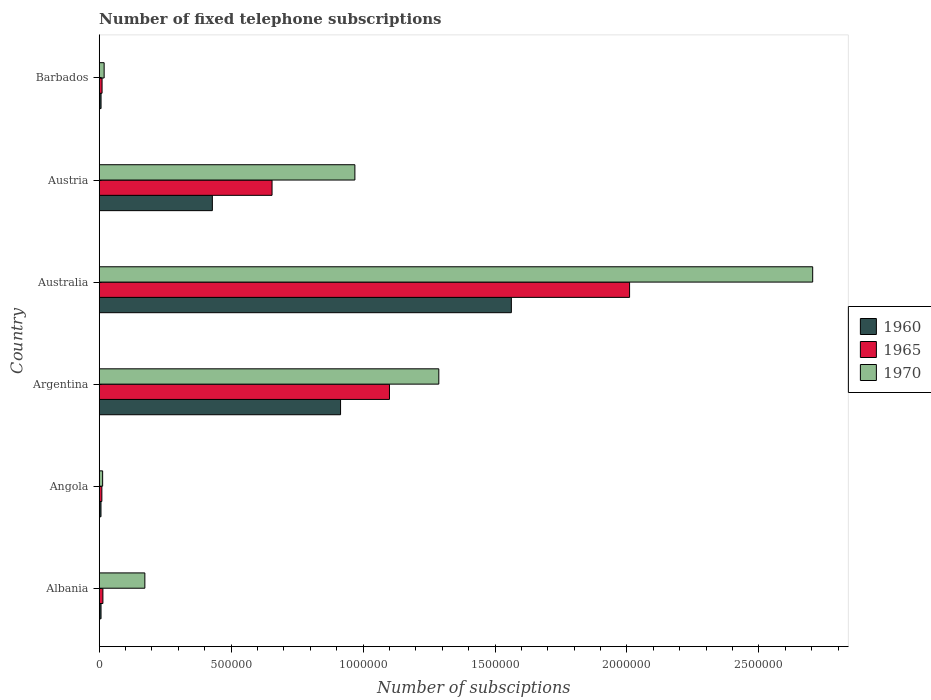How many different coloured bars are there?
Make the answer very short. 3. Are the number of bars per tick equal to the number of legend labels?
Make the answer very short. Yes. Are the number of bars on each tick of the Y-axis equal?
Provide a succinct answer. Yes. How many bars are there on the 5th tick from the bottom?
Your answer should be very brief. 3. What is the label of the 4th group of bars from the top?
Offer a very short reply. Argentina. In how many cases, is the number of bars for a given country not equal to the number of legend labels?
Make the answer very short. 0. What is the number of fixed telephone subscriptions in 1970 in Barbados?
Offer a terse response. 1.87e+04. Across all countries, what is the maximum number of fixed telephone subscriptions in 1970?
Your answer should be compact. 2.70e+06. Across all countries, what is the minimum number of fixed telephone subscriptions in 1970?
Keep it short and to the point. 1.30e+04. In which country was the number of fixed telephone subscriptions in 1965 minimum?
Give a very brief answer. Angola. What is the total number of fixed telephone subscriptions in 1960 in the graph?
Provide a succinct answer. 2.93e+06. What is the difference between the number of fixed telephone subscriptions in 1965 in Albania and that in Austria?
Ensure brevity in your answer.  -6.41e+05. What is the difference between the number of fixed telephone subscriptions in 1960 in Albania and the number of fixed telephone subscriptions in 1970 in Barbados?
Make the answer very short. -1.18e+04. What is the average number of fixed telephone subscriptions in 1965 per country?
Your answer should be compact. 6.33e+05. What is the difference between the number of fixed telephone subscriptions in 1960 and number of fixed telephone subscriptions in 1970 in Barbados?
Your response must be concise. -1.17e+04. In how many countries, is the number of fixed telephone subscriptions in 1965 greater than 900000 ?
Offer a very short reply. 2. What is the ratio of the number of fixed telephone subscriptions in 1960 in Angola to that in Australia?
Give a very brief answer. 0. Is the difference between the number of fixed telephone subscriptions in 1960 in Australia and Austria greater than the difference between the number of fixed telephone subscriptions in 1970 in Australia and Austria?
Provide a succinct answer. No. What is the difference between the highest and the second highest number of fixed telephone subscriptions in 1965?
Your answer should be compact. 9.10e+05. Is the sum of the number of fixed telephone subscriptions in 1970 in Angola and Austria greater than the maximum number of fixed telephone subscriptions in 1965 across all countries?
Your answer should be very brief. No. Is it the case that in every country, the sum of the number of fixed telephone subscriptions in 1970 and number of fixed telephone subscriptions in 1960 is greater than the number of fixed telephone subscriptions in 1965?
Keep it short and to the point. Yes. How many bars are there?
Give a very brief answer. 18. Does the graph contain any zero values?
Your response must be concise. No. Where does the legend appear in the graph?
Provide a short and direct response. Center right. How are the legend labels stacked?
Make the answer very short. Vertical. What is the title of the graph?
Give a very brief answer. Number of fixed telephone subscriptions. What is the label or title of the X-axis?
Your response must be concise. Number of subsciptions. What is the label or title of the Y-axis?
Your answer should be compact. Country. What is the Number of subsciptions in 1960 in Albania?
Give a very brief answer. 6845. What is the Number of subsciptions of 1965 in Albania?
Ensure brevity in your answer.  1.40e+04. What is the Number of subsciptions in 1970 in Albania?
Your answer should be very brief. 1.73e+05. What is the Number of subsciptions of 1960 in Angola?
Ensure brevity in your answer.  6666. What is the Number of subsciptions of 1970 in Angola?
Provide a short and direct response. 1.30e+04. What is the Number of subsciptions in 1960 in Argentina?
Provide a short and direct response. 9.15e+05. What is the Number of subsciptions of 1965 in Argentina?
Give a very brief answer. 1.10e+06. What is the Number of subsciptions in 1970 in Argentina?
Your response must be concise. 1.29e+06. What is the Number of subsciptions of 1960 in Australia?
Ensure brevity in your answer.  1.56e+06. What is the Number of subsciptions of 1965 in Australia?
Your answer should be compact. 2.01e+06. What is the Number of subsciptions of 1970 in Australia?
Offer a terse response. 2.70e+06. What is the Number of subsciptions in 1960 in Austria?
Give a very brief answer. 4.29e+05. What is the Number of subsciptions of 1965 in Austria?
Give a very brief answer. 6.55e+05. What is the Number of subsciptions of 1970 in Austria?
Provide a short and direct response. 9.69e+05. What is the Number of subsciptions in 1960 in Barbados?
Your response must be concise. 6933. What is the Number of subsciptions in 1965 in Barbados?
Offer a very short reply. 1.08e+04. What is the Number of subsciptions in 1970 in Barbados?
Give a very brief answer. 1.87e+04. Across all countries, what is the maximum Number of subsciptions of 1960?
Offer a terse response. 1.56e+06. Across all countries, what is the maximum Number of subsciptions in 1965?
Offer a terse response. 2.01e+06. Across all countries, what is the maximum Number of subsciptions of 1970?
Provide a short and direct response. 2.70e+06. Across all countries, what is the minimum Number of subsciptions of 1960?
Make the answer very short. 6666. Across all countries, what is the minimum Number of subsciptions of 1970?
Your response must be concise. 1.30e+04. What is the total Number of subsciptions in 1960 in the graph?
Your answer should be compact. 2.93e+06. What is the total Number of subsciptions of 1965 in the graph?
Provide a short and direct response. 3.80e+06. What is the total Number of subsciptions in 1970 in the graph?
Provide a short and direct response. 5.16e+06. What is the difference between the Number of subsciptions of 1960 in Albania and that in Angola?
Offer a terse response. 179. What is the difference between the Number of subsciptions of 1965 in Albania and that in Angola?
Provide a short and direct response. 3991. What is the difference between the Number of subsciptions of 1970 in Albania and that in Angola?
Keep it short and to the point. 1.60e+05. What is the difference between the Number of subsciptions of 1960 in Albania and that in Argentina?
Offer a terse response. -9.08e+05. What is the difference between the Number of subsciptions of 1965 in Albania and that in Argentina?
Offer a terse response. -1.09e+06. What is the difference between the Number of subsciptions in 1970 in Albania and that in Argentina?
Your answer should be compact. -1.11e+06. What is the difference between the Number of subsciptions of 1960 in Albania and that in Australia?
Your response must be concise. -1.56e+06. What is the difference between the Number of subsciptions of 1965 in Albania and that in Australia?
Make the answer very short. -2.00e+06. What is the difference between the Number of subsciptions of 1970 in Albania and that in Australia?
Offer a very short reply. -2.53e+06. What is the difference between the Number of subsciptions in 1960 in Albania and that in Austria?
Your answer should be very brief. -4.22e+05. What is the difference between the Number of subsciptions in 1965 in Albania and that in Austria?
Your response must be concise. -6.41e+05. What is the difference between the Number of subsciptions of 1970 in Albania and that in Austria?
Your answer should be compact. -7.96e+05. What is the difference between the Number of subsciptions of 1960 in Albania and that in Barbados?
Give a very brief answer. -88. What is the difference between the Number of subsciptions of 1965 in Albania and that in Barbados?
Offer a terse response. 3190. What is the difference between the Number of subsciptions in 1970 in Albania and that in Barbados?
Make the answer very short. 1.54e+05. What is the difference between the Number of subsciptions in 1960 in Angola and that in Argentina?
Keep it short and to the point. -9.08e+05. What is the difference between the Number of subsciptions of 1965 in Angola and that in Argentina?
Make the answer very short. -1.09e+06. What is the difference between the Number of subsciptions of 1970 in Angola and that in Argentina?
Your answer should be compact. -1.27e+06. What is the difference between the Number of subsciptions of 1960 in Angola and that in Australia?
Provide a succinct answer. -1.56e+06. What is the difference between the Number of subsciptions in 1970 in Angola and that in Australia?
Offer a terse response. -2.69e+06. What is the difference between the Number of subsciptions of 1960 in Angola and that in Austria?
Keep it short and to the point. -4.22e+05. What is the difference between the Number of subsciptions in 1965 in Angola and that in Austria?
Your answer should be compact. -6.45e+05. What is the difference between the Number of subsciptions of 1970 in Angola and that in Austria?
Offer a terse response. -9.56e+05. What is the difference between the Number of subsciptions of 1960 in Angola and that in Barbados?
Provide a short and direct response. -267. What is the difference between the Number of subsciptions in 1965 in Angola and that in Barbados?
Your answer should be very brief. -801. What is the difference between the Number of subsciptions in 1970 in Angola and that in Barbados?
Offer a very short reply. -5682. What is the difference between the Number of subsciptions of 1960 in Argentina and that in Australia?
Offer a terse response. -6.47e+05. What is the difference between the Number of subsciptions in 1965 in Argentina and that in Australia?
Give a very brief answer. -9.10e+05. What is the difference between the Number of subsciptions in 1970 in Argentina and that in Australia?
Make the answer very short. -1.42e+06. What is the difference between the Number of subsciptions in 1960 in Argentina and that in Austria?
Your answer should be very brief. 4.86e+05. What is the difference between the Number of subsciptions in 1965 in Argentina and that in Austria?
Ensure brevity in your answer.  4.45e+05. What is the difference between the Number of subsciptions of 1970 in Argentina and that in Austria?
Provide a short and direct response. 3.18e+05. What is the difference between the Number of subsciptions in 1960 in Argentina and that in Barbados?
Your answer should be very brief. 9.08e+05. What is the difference between the Number of subsciptions in 1965 in Argentina and that in Barbados?
Offer a very short reply. 1.09e+06. What is the difference between the Number of subsciptions in 1970 in Argentina and that in Barbados?
Your answer should be compact. 1.27e+06. What is the difference between the Number of subsciptions in 1960 in Australia and that in Austria?
Provide a succinct answer. 1.13e+06. What is the difference between the Number of subsciptions in 1965 in Australia and that in Austria?
Provide a short and direct response. 1.36e+06. What is the difference between the Number of subsciptions in 1970 in Australia and that in Austria?
Offer a terse response. 1.74e+06. What is the difference between the Number of subsciptions of 1960 in Australia and that in Barbados?
Give a very brief answer. 1.56e+06. What is the difference between the Number of subsciptions in 1965 in Australia and that in Barbados?
Make the answer very short. 2.00e+06. What is the difference between the Number of subsciptions in 1970 in Australia and that in Barbados?
Your response must be concise. 2.69e+06. What is the difference between the Number of subsciptions in 1960 in Austria and that in Barbados?
Your answer should be compact. 4.22e+05. What is the difference between the Number of subsciptions of 1965 in Austria and that in Barbados?
Your answer should be compact. 6.44e+05. What is the difference between the Number of subsciptions of 1970 in Austria and that in Barbados?
Ensure brevity in your answer.  9.50e+05. What is the difference between the Number of subsciptions in 1960 in Albania and the Number of subsciptions in 1965 in Angola?
Give a very brief answer. -3155. What is the difference between the Number of subsciptions in 1960 in Albania and the Number of subsciptions in 1970 in Angola?
Your answer should be compact. -6155. What is the difference between the Number of subsciptions in 1965 in Albania and the Number of subsciptions in 1970 in Angola?
Offer a terse response. 991. What is the difference between the Number of subsciptions of 1960 in Albania and the Number of subsciptions of 1965 in Argentina?
Make the answer very short. -1.09e+06. What is the difference between the Number of subsciptions in 1960 in Albania and the Number of subsciptions in 1970 in Argentina?
Make the answer very short. -1.28e+06. What is the difference between the Number of subsciptions of 1965 in Albania and the Number of subsciptions of 1970 in Argentina?
Give a very brief answer. -1.27e+06. What is the difference between the Number of subsciptions of 1960 in Albania and the Number of subsciptions of 1965 in Australia?
Provide a succinct answer. -2.00e+06. What is the difference between the Number of subsciptions of 1960 in Albania and the Number of subsciptions of 1970 in Australia?
Provide a short and direct response. -2.70e+06. What is the difference between the Number of subsciptions in 1965 in Albania and the Number of subsciptions in 1970 in Australia?
Provide a succinct answer. -2.69e+06. What is the difference between the Number of subsciptions in 1960 in Albania and the Number of subsciptions in 1965 in Austria?
Your answer should be compact. -6.48e+05. What is the difference between the Number of subsciptions of 1960 in Albania and the Number of subsciptions of 1970 in Austria?
Ensure brevity in your answer.  -9.62e+05. What is the difference between the Number of subsciptions in 1965 in Albania and the Number of subsciptions in 1970 in Austria?
Your answer should be compact. -9.55e+05. What is the difference between the Number of subsciptions in 1960 in Albania and the Number of subsciptions in 1965 in Barbados?
Your answer should be compact. -3956. What is the difference between the Number of subsciptions of 1960 in Albania and the Number of subsciptions of 1970 in Barbados?
Ensure brevity in your answer.  -1.18e+04. What is the difference between the Number of subsciptions of 1965 in Albania and the Number of subsciptions of 1970 in Barbados?
Offer a very short reply. -4691. What is the difference between the Number of subsciptions of 1960 in Angola and the Number of subsciptions of 1965 in Argentina?
Give a very brief answer. -1.09e+06. What is the difference between the Number of subsciptions of 1960 in Angola and the Number of subsciptions of 1970 in Argentina?
Offer a terse response. -1.28e+06. What is the difference between the Number of subsciptions of 1965 in Angola and the Number of subsciptions of 1970 in Argentina?
Make the answer very short. -1.28e+06. What is the difference between the Number of subsciptions of 1960 in Angola and the Number of subsciptions of 1965 in Australia?
Your answer should be compact. -2.00e+06. What is the difference between the Number of subsciptions of 1960 in Angola and the Number of subsciptions of 1970 in Australia?
Offer a terse response. -2.70e+06. What is the difference between the Number of subsciptions in 1965 in Angola and the Number of subsciptions in 1970 in Australia?
Make the answer very short. -2.69e+06. What is the difference between the Number of subsciptions in 1960 in Angola and the Number of subsciptions in 1965 in Austria?
Offer a terse response. -6.48e+05. What is the difference between the Number of subsciptions of 1960 in Angola and the Number of subsciptions of 1970 in Austria?
Offer a terse response. -9.62e+05. What is the difference between the Number of subsciptions in 1965 in Angola and the Number of subsciptions in 1970 in Austria?
Your answer should be very brief. -9.59e+05. What is the difference between the Number of subsciptions in 1960 in Angola and the Number of subsciptions in 1965 in Barbados?
Provide a short and direct response. -4135. What is the difference between the Number of subsciptions of 1960 in Angola and the Number of subsciptions of 1970 in Barbados?
Offer a very short reply. -1.20e+04. What is the difference between the Number of subsciptions of 1965 in Angola and the Number of subsciptions of 1970 in Barbados?
Offer a terse response. -8682. What is the difference between the Number of subsciptions in 1960 in Argentina and the Number of subsciptions in 1965 in Australia?
Your answer should be compact. -1.10e+06. What is the difference between the Number of subsciptions of 1960 in Argentina and the Number of subsciptions of 1970 in Australia?
Provide a succinct answer. -1.79e+06. What is the difference between the Number of subsciptions in 1965 in Argentina and the Number of subsciptions in 1970 in Australia?
Ensure brevity in your answer.  -1.60e+06. What is the difference between the Number of subsciptions in 1960 in Argentina and the Number of subsciptions in 1965 in Austria?
Make the answer very short. 2.60e+05. What is the difference between the Number of subsciptions of 1960 in Argentina and the Number of subsciptions of 1970 in Austria?
Make the answer very short. -5.43e+04. What is the difference between the Number of subsciptions in 1965 in Argentina and the Number of subsciptions in 1970 in Austria?
Your response must be concise. 1.31e+05. What is the difference between the Number of subsciptions in 1960 in Argentina and the Number of subsciptions in 1965 in Barbados?
Keep it short and to the point. 9.04e+05. What is the difference between the Number of subsciptions in 1960 in Argentina and the Number of subsciptions in 1970 in Barbados?
Offer a terse response. 8.96e+05. What is the difference between the Number of subsciptions in 1965 in Argentina and the Number of subsciptions in 1970 in Barbados?
Make the answer very short. 1.08e+06. What is the difference between the Number of subsciptions of 1960 in Australia and the Number of subsciptions of 1965 in Austria?
Your answer should be very brief. 9.07e+05. What is the difference between the Number of subsciptions in 1960 in Australia and the Number of subsciptions in 1970 in Austria?
Offer a terse response. 5.93e+05. What is the difference between the Number of subsciptions of 1965 in Australia and the Number of subsciptions of 1970 in Austria?
Keep it short and to the point. 1.04e+06. What is the difference between the Number of subsciptions of 1960 in Australia and the Number of subsciptions of 1965 in Barbados?
Provide a succinct answer. 1.55e+06. What is the difference between the Number of subsciptions of 1960 in Australia and the Number of subsciptions of 1970 in Barbados?
Your answer should be very brief. 1.54e+06. What is the difference between the Number of subsciptions in 1965 in Australia and the Number of subsciptions in 1970 in Barbados?
Make the answer very short. 1.99e+06. What is the difference between the Number of subsciptions in 1960 in Austria and the Number of subsciptions in 1965 in Barbados?
Your answer should be compact. 4.18e+05. What is the difference between the Number of subsciptions of 1960 in Austria and the Number of subsciptions of 1970 in Barbados?
Provide a short and direct response. 4.10e+05. What is the difference between the Number of subsciptions of 1965 in Austria and the Number of subsciptions of 1970 in Barbados?
Ensure brevity in your answer.  6.36e+05. What is the average Number of subsciptions in 1960 per country?
Keep it short and to the point. 4.88e+05. What is the average Number of subsciptions of 1965 per country?
Offer a terse response. 6.33e+05. What is the average Number of subsciptions in 1970 per country?
Ensure brevity in your answer.  8.61e+05. What is the difference between the Number of subsciptions in 1960 and Number of subsciptions in 1965 in Albania?
Offer a terse response. -7146. What is the difference between the Number of subsciptions in 1960 and Number of subsciptions in 1970 in Albania?
Keep it short and to the point. -1.66e+05. What is the difference between the Number of subsciptions in 1965 and Number of subsciptions in 1970 in Albania?
Provide a succinct answer. -1.59e+05. What is the difference between the Number of subsciptions of 1960 and Number of subsciptions of 1965 in Angola?
Your answer should be very brief. -3334. What is the difference between the Number of subsciptions of 1960 and Number of subsciptions of 1970 in Angola?
Offer a terse response. -6334. What is the difference between the Number of subsciptions in 1965 and Number of subsciptions in 1970 in Angola?
Your answer should be very brief. -3000. What is the difference between the Number of subsciptions of 1960 and Number of subsciptions of 1965 in Argentina?
Provide a succinct answer. -1.85e+05. What is the difference between the Number of subsciptions in 1960 and Number of subsciptions in 1970 in Argentina?
Keep it short and to the point. -3.72e+05. What is the difference between the Number of subsciptions in 1965 and Number of subsciptions in 1970 in Argentina?
Give a very brief answer. -1.87e+05. What is the difference between the Number of subsciptions in 1960 and Number of subsciptions in 1965 in Australia?
Give a very brief answer. -4.48e+05. What is the difference between the Number of subsciptions of 1960 and Number of subsciptions of 1970 in Australia?
Keep it short and to the point. -1.14e+06. What is the difference between the Number of subsciptions of 1965 and Number of subsciptions of 1970 in Australia?
Your answer should be very brief. -6.94e+05. What is the difference between the Number of subsciptions in 1960 and Number of subsciptions in 1965 in Austria?
Provide a short and direct response. -2.26e+05. What is the difference between the Number of subsciptions of 1960 and Number of subsciptions of 1970 in Austria?
Keep it short and to the point. -5.40e+05. What is the difference between the Number of subsciptions of 1965 and Number of subsciptions of 1970 in Austria?
Offer a terse response. -3.14e+05. What is the difference between the Number of subsciptions of 1960 and Number of subsciptions of 1965 in Barbados?
Make the answer very short. -3868. What is the difference between the Number of subsciptions of 1960 and Number of subsciptions of 1970 in Barbados?
Provide a short and direct response. -1.17e+04. What is the difference between the Number of subsciptions in 1965 and Number of subsciptions in 1970 in Barbados?
Offer a very short reply. -7881. What is the ratio of the Number of subsciptions of 1960 in Albania to that in Angola?
Provide a short and direct response. 1.03. What is the ratio of the Number of subsciptions of 1965 in Albania to that in Angola?
Your response must be concise. 1.4. What is the ratio of the Number of subsciptions of 1970 in Albania to that in Angola?
Offer a very short reply. 13.31. What is the ratio of the Number of subsciptions in 1960 in Albania to that in Argentina?
Provide a short and direct response. 0.01. What is the ratio of the Number of subsciptions in 1965 in Albania to that in Argentina?
Offer a terse response. 0.01. What is the ratio of the Number of subsciptions in 1970 in Albania to that in Argentina?
Your response must be concise. 0.13. What is the ratio of the Number of subsciptions in 1960 in Albania to that in Australia?
Ensure brevity in your answer.  0. What is the ratio of the Number of subsciptions in 1965 in Albania to that in Australia?
Your answer should be compact. 0.01. What is the ratio of the Number of subsciptions in 1970 in Albania to that in Australia?
Provide a short and direct response. 0.06. What is the ratio of the Number of subsciptions of 1960 in Albania to that in Austria?
Keep it short and to the point. 0.02. What is the ratio of the Number of subsciptions in 1965 in Albania to that in Austria?
Your answer should be compact. 0.02. What is the ratio of the Number of subsciptions in 1970 in Albania to that in Austria?
Your response must be concise. 0.18. What is the ratio of the Number of subsciptions in 1960 in Albania to that in Barbados?
Your answer should be compact. 0.99. What is the ratio of the Number of subsciptions in 1965 in Albania to that in Barbados?
Your answer should be compact. 1.3. What is the ratio of the Number of subsciptions in 1970 in Albania to that in Barbados?
Your answer should be very brief. 9.26. What is the ratio of the Number of subsciptions in 1960 in Angola to that in Argentina?
Keep it short and to the point. 0.01. What is the ratio of the Number of subsciptions of 1965 in Angola to that in Argentina?
Offer a very short reply. 0.01. What is the ratio of the Number of subsciptions of 1970 in Angola to that in Argentina?
Your answer should be compact. 0.01. What is the ratio of the Number of subsciptions in 1960 in Angola to that in Australia?
Offer a very short reply. 0. What is the ratio of the Number of subsciptions in 1965 in Angola to that in Australia?
Keep it short and to the point. 0.01. What is the ratio of the Number of subsciptions of 1970 in Angola to that in Australia?
Offer a terse response. 0. What is the ratio of the Number of subsciptions in 1960 in Angola to that in Austria?
Make the answer very short. 0.02. What is the ratio of the Number of subsciptions in 1965 in Angola to that in Austria?
Ensure brevity in your answer.  0.02. What is the ratio of the Number of subsciptions of 1970 in Angola to that in Austria?
Offer a terse response. 0.01. What is the ratio of the Number of subsciptions of 1960 in Angola to that in Barbados?
Your response must be concise. 0.96. What is the ratio of the Number of subsciptions in 1965 in Angola to that in Barbados?
Your answer should be compact. 0.93. What is the ratio of the Number of subsciptions of 1970 in Angola to that in Barbados?
Keep it short and to the point. 0.7. What is the ratio of the Number of subsciptions in 1960 in Argentina to that in Australia?
Offer a very short reply. 0.59. What is the ratio of the Number of subsciptions of 1965 in Argentina to that in Australia?
Keep it short and to the point. 0.55. What is the ratio of the Number of subsciptions of 1970 in Argentina to that in Australia?
Your answer should be very brief. 0.48. What is the ratio of the Number of subsciptions of 1960 in Argentina to that in Austria?
Your answer should be compact. 2.13. What is the ratio of the Number of subsciptions in 1965 in Argentina to that in Austria?
Your response must be concise. 1.68. What is the ratio of the Number of subsciptions in 1970 in Argentina to that in Austria?
Give a very brief answer. 1.33. What is the ratio of the Number of subsciptions of 1960 in Argentina to that in Barbados?
Offer a very short reply. 131.93. What is the ratio of the Number of subsciptions of 1965 in Argentina to that in Barbados?
Ensure brevity in your answer.  101.84. What is the ratio of the Number of subsciptions of 1970 in Argentina to that in Barbados?
Give a very brief answer. 68.89. What is the ratio of the Number of subsciptions of 1960 in Australia to that in Austria?
Offer a terse response. 3.64. What is the ratio of the Number of subsciptions of 1965 in Australia to that in Austria?
Offer a very short reply. 3.07. What is the ratio of the Number of subsciptions in 1970 in Australia to that in Austria?
Provide a short and direct response. 2.79. What is the ratio of the Number of subsciptions of 1960 in Australia to that in Barbados?
Make the answer very short. 225.29. What is the ratio of the Number of subsciptions of 1965 in Australia to that in Barbados?
Your answer should be compact. 186.09. What is the ratio of the Number of subsciptions in 1970 in Australia to that in Barbados?
Provide a short and direct response. 144.74. What is the ratio of the Number of subsciptions of 1960 in Austria to that in Barbados?
Provide a succinct answer. 61.85. What is the ratio of the Number of subsciptions in 1965 in Austria to that in Barbados?
Keep it short and to the point. 60.64. What is the ratio of the Number of subsciptions of 1970 in Austria to that in Barbados?
Provide a short and direct response. 51.87. What is the difference between the highest and the second highest Number of subsciptions of 1960?
Your response must be concise. 6.47e+05. What is the difference between the highest and the second highest Number of subsciptions of 1965?
Give a very brief answer. 9.10e+05. What is the difference between the highest and the second highest Number of subsciptions of 1970?
Make the answer very short. 1.42e+06. What is the difference between the highest and the lowest Number of subsciptions of 1960?
Offer a very short reply. 1.56e+06. What is the difference between the highest and the lowest Number of subsciptions in 1965?
Offer a very short reply. 2.00e+06. What is the difference between the highest and the lowest Number of subsciptions in 1970?
Offer a terse response. 2.69e+06. 